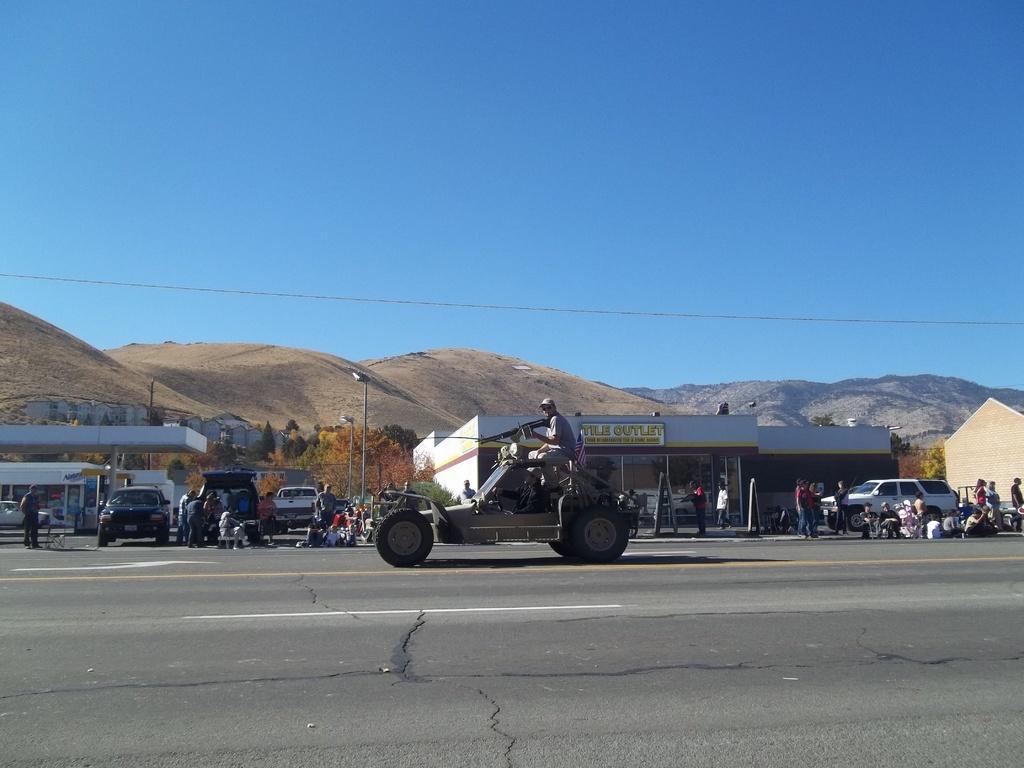In one or two sentences, can you explain what this image depicts? In the image there are few vehicles parked beside the road and around the vehicles some people are sitting on the road, there is another vehicle moving on the road and behind the vehicles there is a store and in the background there are small mountains. 